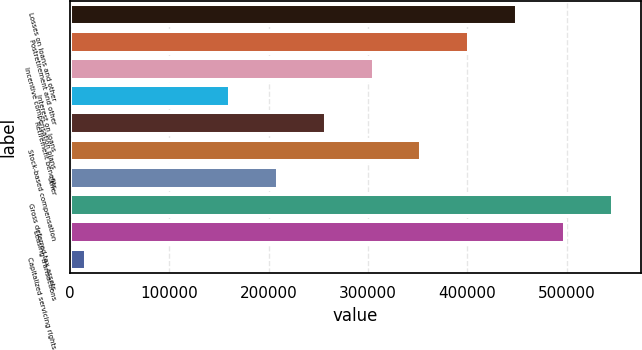Convert chart. <chart><loc_0><loc_0><loc_500><loc_500><bar_chart><fcel>Losses on loans and other<fcel>Postretirement and other<fcel>Incentive compensation plans<fcel>Interest on loans<fcel>Retirement benefits<fcel>Stock-based compensation<fcel>Other<fcel>Gross deferred tax assets<fcel>Leasing transactions<fcel>Capitalized servicing rights<nl><fcel>450247<fcel>402020<fcel>305565<fcel>160882<fcel>257337<fcel>353792<fcel>209109<fcel>546703<fcel>498475<fcel>16199<nl></chart> 